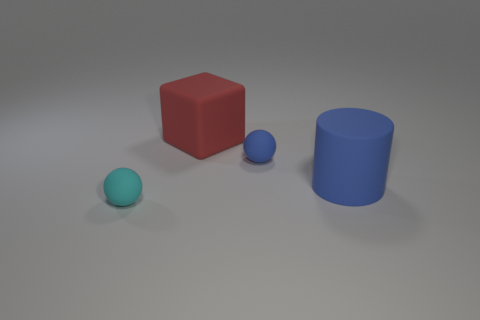Subtract 0 blue blocks. How many objects are left? 4 Subtract all cubes. How many objects are left? 3 Subtract 1 balls. How many balls are left? 1 Subtract all red cylinders. Subtract all green cubes. How many cylinders are left? 1 Subtract all gray cubes. How many brown cylinders are left? 0 Subtract all green shiny cubes. Subtract all cyan rubber objects. How many objects are left? 3 Add 4 blue spheres. How many blue spheres are left? 5 Add 1 large things. How many large things exist? 3 Add 4 blue matte things. How many objects exist? 8 Subtract all blue spheres. How many spheres are left? 1 